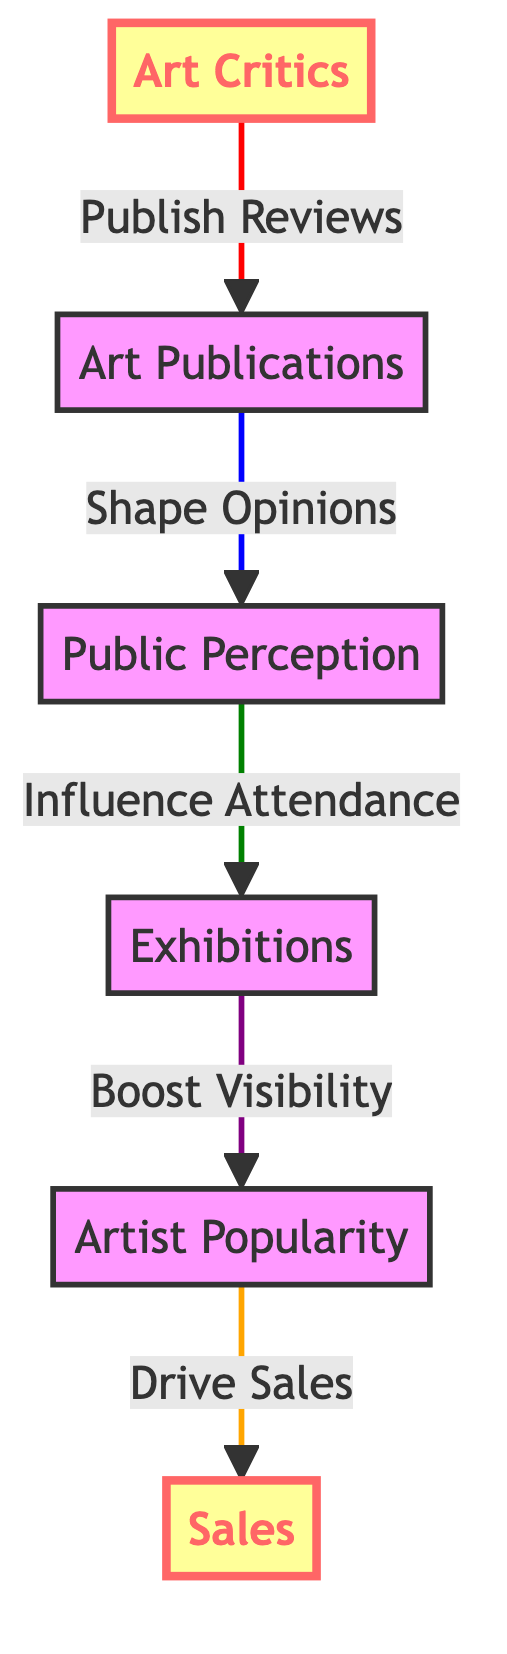What is the first node in the diagram? The first node is "Art Critics," which is the starting point of the flow in this diagram, indicating the primary influence on artist popularity.
Answer: Art Critics How many nodes are in the diagram? The diagram contains six nodes, each representing a different component in the influence of art critics on artist popularity.
Answer: Six What is the relationship between "Art Publications" and "Public Perception"? "Art Publications" influences "Public Perception" through its ability to shape opinions, as indicated by the directed edge from Art Publications to Public Perception.
Answer: Shape Opinions Which node directly leads to "Sales"? The node "Artist Popularity" directly leads to "Sales," indicating that artist popularity is a factor that drives sales in the art market.
Answer: Artist Popularity What influences attendance at exhibitions? "Public Perception" influences attendance at exhibitions, as the diagram specifies that it impacts how many people attend these events based on their formed opinions.
Answer: Public Perception Which components are considered special nodes? The special nodes are "Art Critics" and "Sales," which are highlighted differently in the diagram to denote their significance in the flow of influence.
Answer: Art Critics, Sales What is the effect of "Exhibitions" on "Artist Popularity"? "Exhibitions" boost "Artist Popularity," as shown in the diagram that connects these two nodes, illustrating that increased visibility leads to greater popularity among artists.
Answer: Boost Visibility What does "Art Critics" do according to the diagram? "Art Critics" publish reviews, according to the lead role in the diagram that indicates their function as the starting influence in this chain.
Answer: Publish Reviews How does "Public Perception" influence "Exhibitions"? "Public Perception" affects "Exhibitions" by influencing attendance, suggesting that when public perception is positive, more people are likely to attend the exhibitions.
Answer: Influence Attendance 